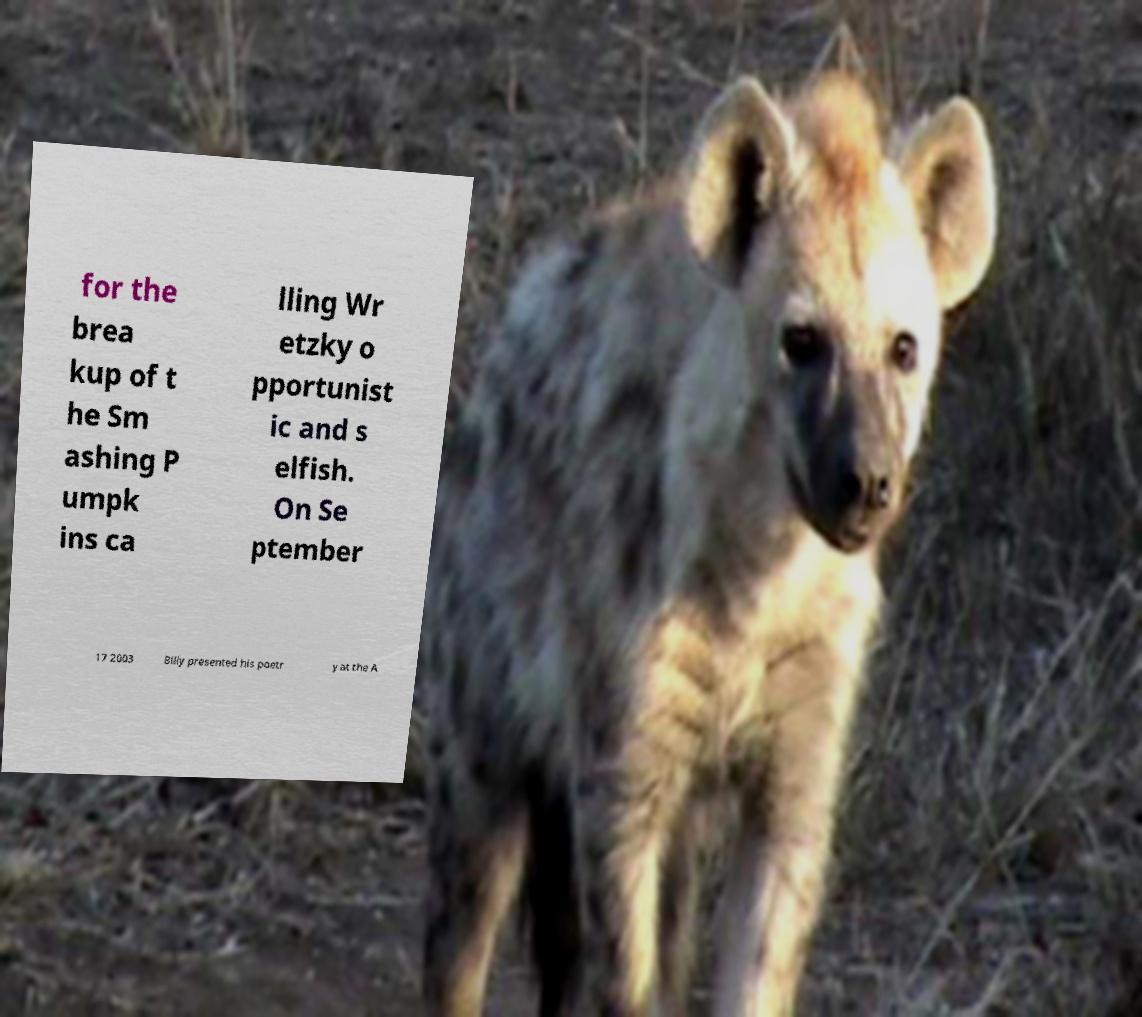For documentation purposes, I need the text within this image transcribed. Could you provide that? for the brea kup of t he Sm ashing P umpk ins ca lling Wr etzky o pportunist ic and s elfish. On Se ptember 17 2003 Billy presented his poetr y at the A 